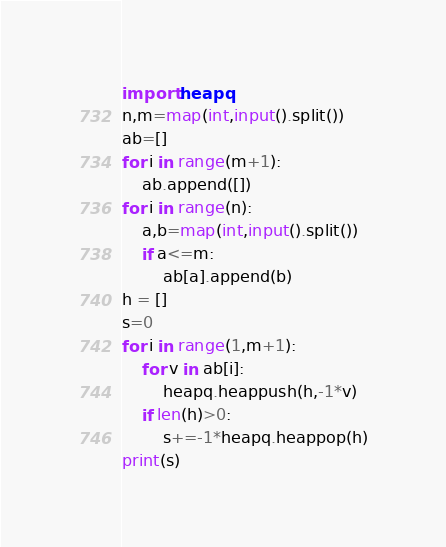Convert code to text. <code><loc_0><loc_0><loc_500><loc_500><_Python_>import heapq
n,m=map(int,input().split())
ab=[]
for i in range(m+1):
    ab.append([])
for i in range(n):
    a,b=map(int,input().split())
    if a<=m:
        ab[a].append(b)
h = []
s=0
for i in range(1,m+1):
    for v in ab[i]:
        heapq.heappush(h,-1*v)
    if len(h)>0:
        s+=-1*heapq.heappop(h)
print(s)</code> 